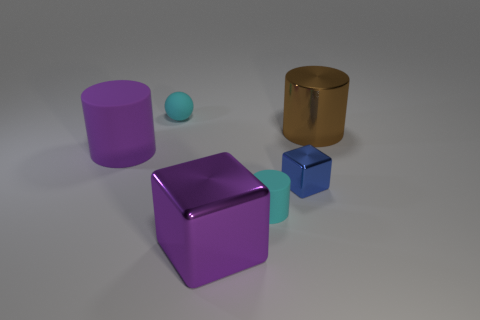Subtract all large cylinders. How many cylinders are left? 1 Subtract all blue cubes. How many cubes are left? 1 Subtract 1 spheres. How many spheres are left? 0 Add 1 big purple rubber things. How many objects exist? 7 Subtract all cyan spheres. How many green cubes are left? 0 Subtract all large objects. Subtract all metal things. How many objects are left? 0 Add 2 blue metal objects. How many blue metal objects are left? 3 Add 4 small cyan cylinders. How many small cyan cylinders exist? 5 Subtract 0 green cubes. How many objects are left? 6 Subtract all blocks. How many objects are left? 4 